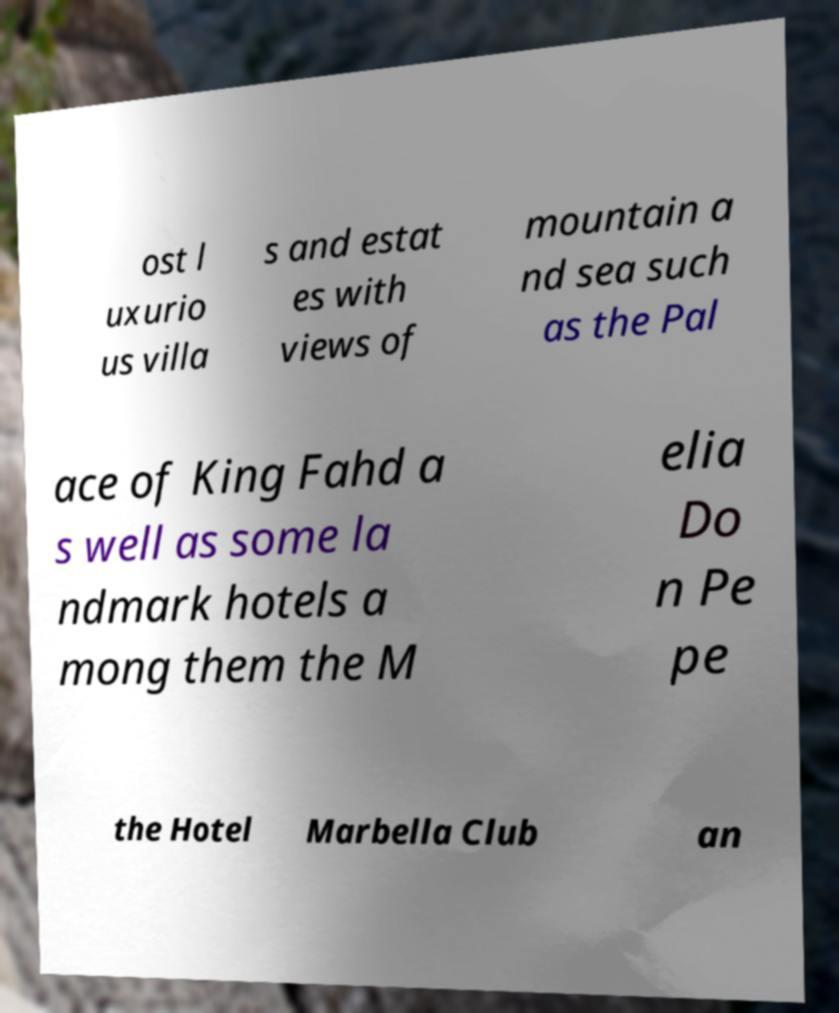Can you accurately transcribe the text from the provided image for me? ost l uxurio us villa s and estat es with views of mountain a nd sea such as the Pal ace of King Fahd a s well as some la ndmark hotels a mong them the M elia Do n Pe pe the Hotel Marbella Club an 